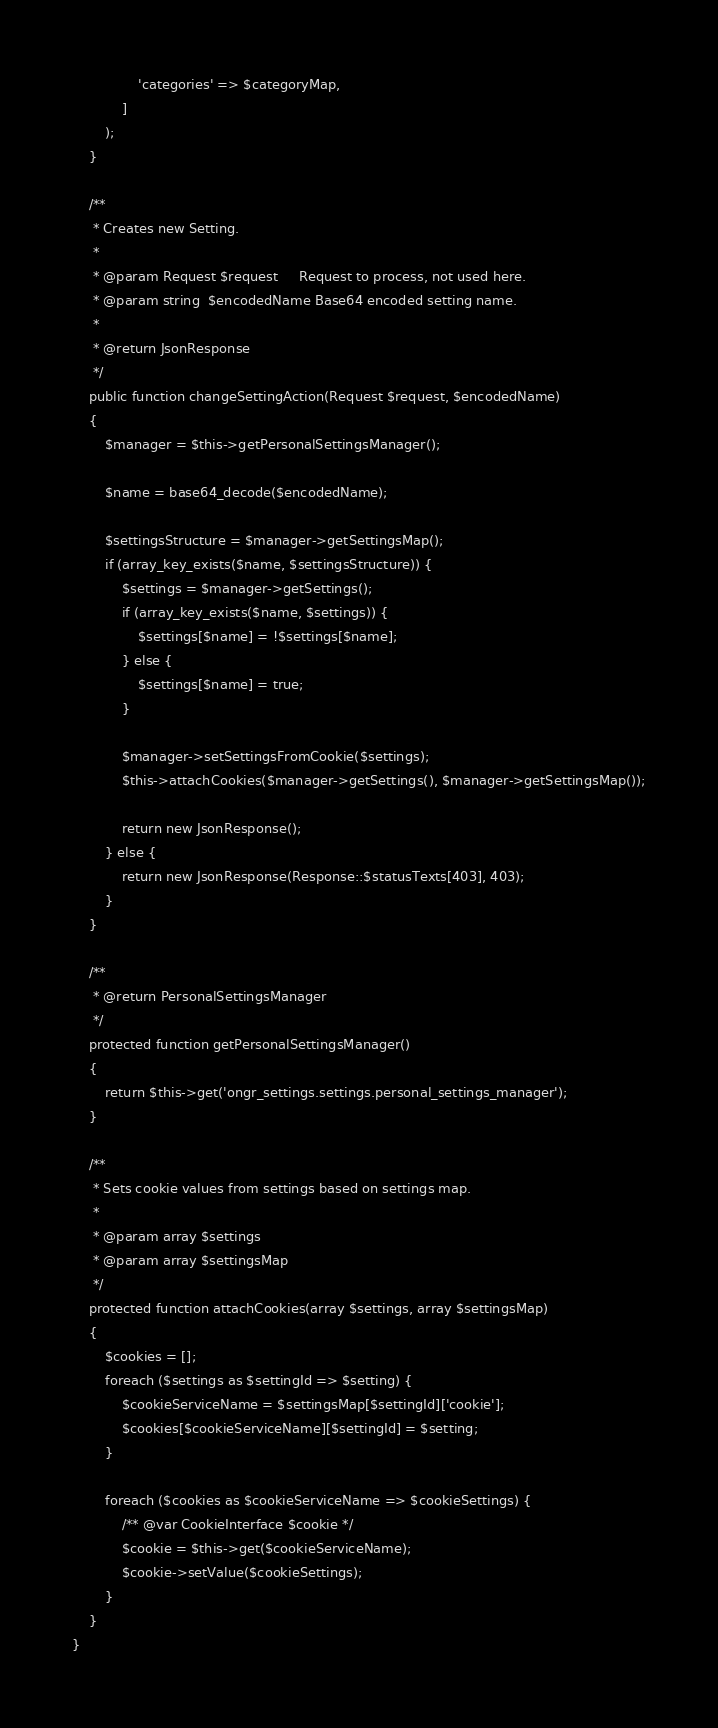<code> <loc_0><loc_0><loc_500><loc_500><_PHP_>                'categories' => $categoryMap,
            ]
        );
    }

    /**
     * Creates new Setting.
     *
     * @param Request $request     Request to process, not used here.
     * @param string  $encodedName Base64 encoded setting name.
     *
     * @return JsonResponse
     */
    public function changeSettingAction(Request $request, $encodedName)
    {
        $manager = $this->getPersonalSettingsManager();

        $name = base64_decode($encodedName);

        $settingsStructure = $manager->getSettingsMap();
        if (array_key_exists($name, $settingsStructure)) {
            $settings = $manager->getSettings();
            if (array_key_exists($name, $settings)) {
                $settings[$name] = !$settings[$name];
            } else {
                $settings[$name] = true;
            }

            $manager->setSettingsFromCookie($settings);
            $this->attachCookies($manager->getSettings(), $manager->getSettingsMap());

            return new JsonResponse();
        } else {
            return new JsonResponse(Response::$statusTexts[403], 403);
        }
    }

    /**
     * @return PersonalSettingsManager
     */
    protected function getPersonalSettingsManager()
    {
        return $this->get('ongr_settings.settings.personal_settings_manager');
    }

    /**
     * Sets cookie values from settings based on settings map.
     *
     * @param array $settings
     * @param array $settingsMap
     */
    protected function attachCookies(array $settings, array $settingsMap)
    {
        $cookies = [];
        foreach ($settings as $settingId => $setting) {
            $cookieServiceName = $settingsMap[$settingId]['cookie'];
            $cookies[$cookieServiceName][$settingId] = $setting;
        }

        foreach ($cookies as $cookieServiceName => $cookieSettings) {
            /** @var CookieInterface $cookie */
            $cookie = $this->get($cookieServiceName);
            $cookie->setValue($cookieSettings);
        }
    }
}
</code> 